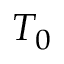Convert formula to latex. <formula><loc_0><loc_0><loc_500><loc_500>T _ { 0 }</formula> 